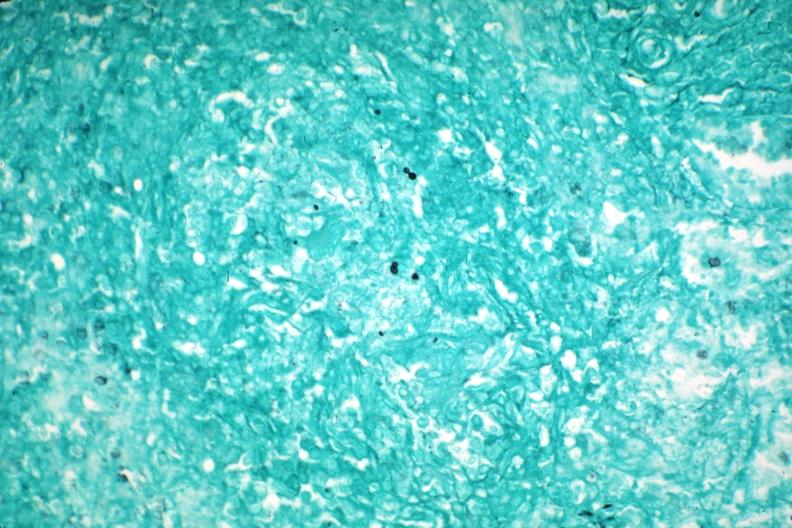why does this image show gms granuloma?
Answer the question using a single word or phrase. Due to pneumocystis aids case 